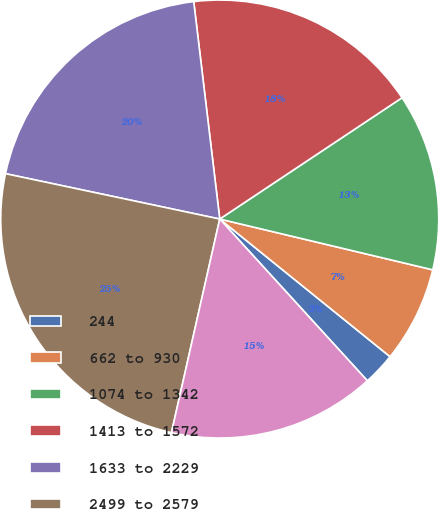<chart> <loc_0><loc_0><loc_500><loc_500><pie_chart><fcel>244<fcel>662 to 930<fcel>1074 to 1342<fcel>1413 to 1572<fcel>1633 to 2229<fcel>2499 to 2579<fcel>Total<nl><fcel>2.41%<fcel>7.09%<fcel>13.07%<fcel>17.55%<fcel>19.78%<fcel>24.78%<fcel>15.31%<nl></chart> 